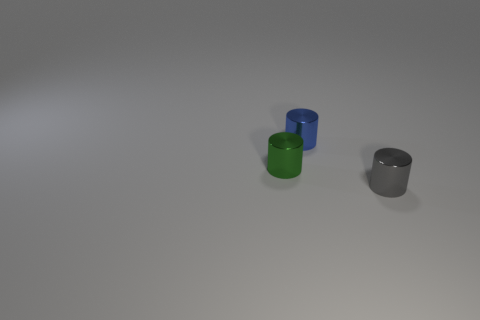The blue object that is made of the same material as the tiny green cylinder is what size?
Offer a terse response. Small. How many other tiny metallic things are the same shape as the small gray object?
Provide a succinct answer. 2. Are there more tiny cylinders right of the green cylinder than metallic things?
Offer a terse response. No. The small shiny object that is in front of the small blue cylinder and behind the gray metal object has what shape?
Your answer should be very brief. Cylinder. Is the green shiny cylinder the same size as the blue cylinder?
Give a very brief answer. Yes. What number of small gray objects are in front of the tiny green metallic cylinder?
Provide a succinct answer. 1. Are there the same number of tiny green objects that are to the left of the tiny green cylinder and green metal cylinders that are in front of the blue shiny cylinder?
Your answer should be very brief. No. There is a tiny object that is left of the tiny blue shiny cylinder; does it have the same shape as the small blue object?
Give a very brief answer. Yes. Is there any other thing that has the same material as the tiny green thing?
Offer a very short reply. Yes. There is a gray cylinder; is its size the same as the thing that is to the left of the tiny blue cylinder?
Keep it short and to the point. Yes. 